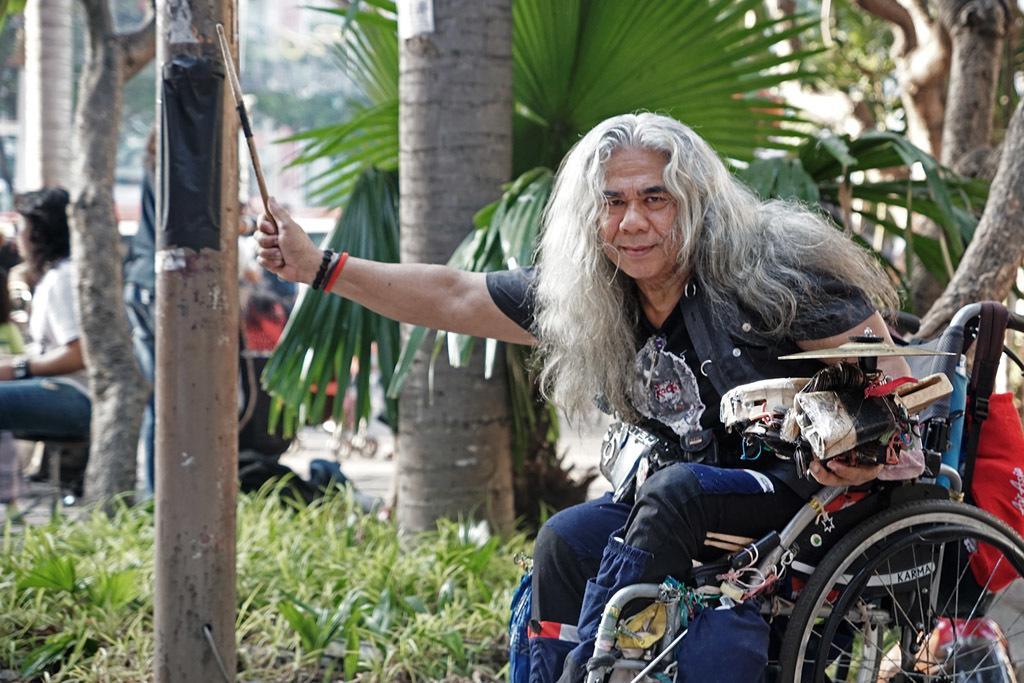How would you summarize this image in a sentence or two? In this image we can see a person sitting on the wheelchair and there are trees. At the bottom there is grass. In the background there are people. 